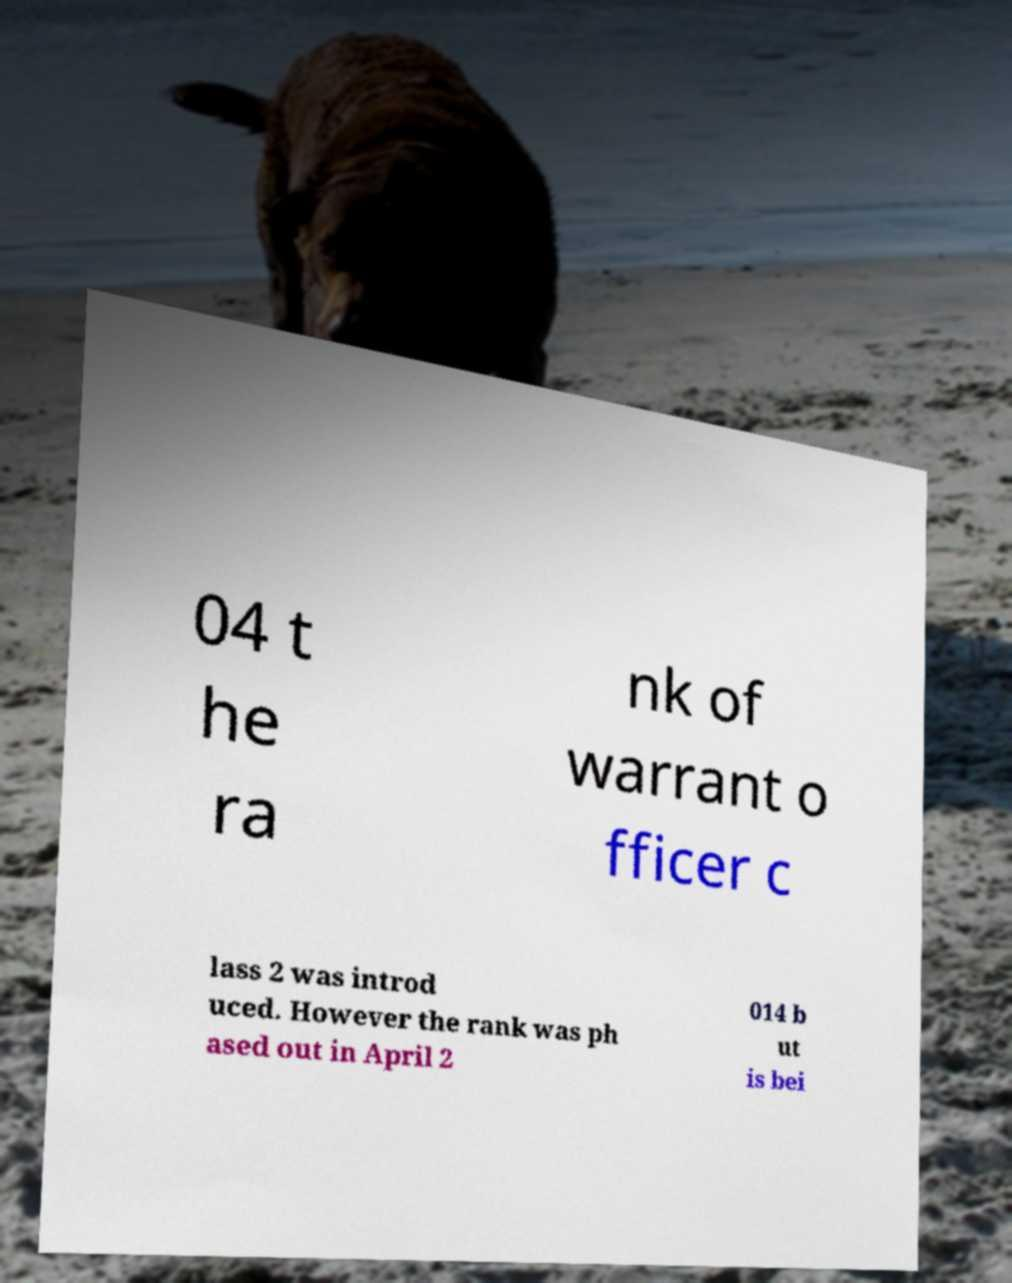For documentation purposes, I need the text within this image transcribed. Could you provide that? 04 t he ra nk of warrant o fficer c lass 2 was introd uced. However the rank was ph ased out in April 2 014 b ut is bei 